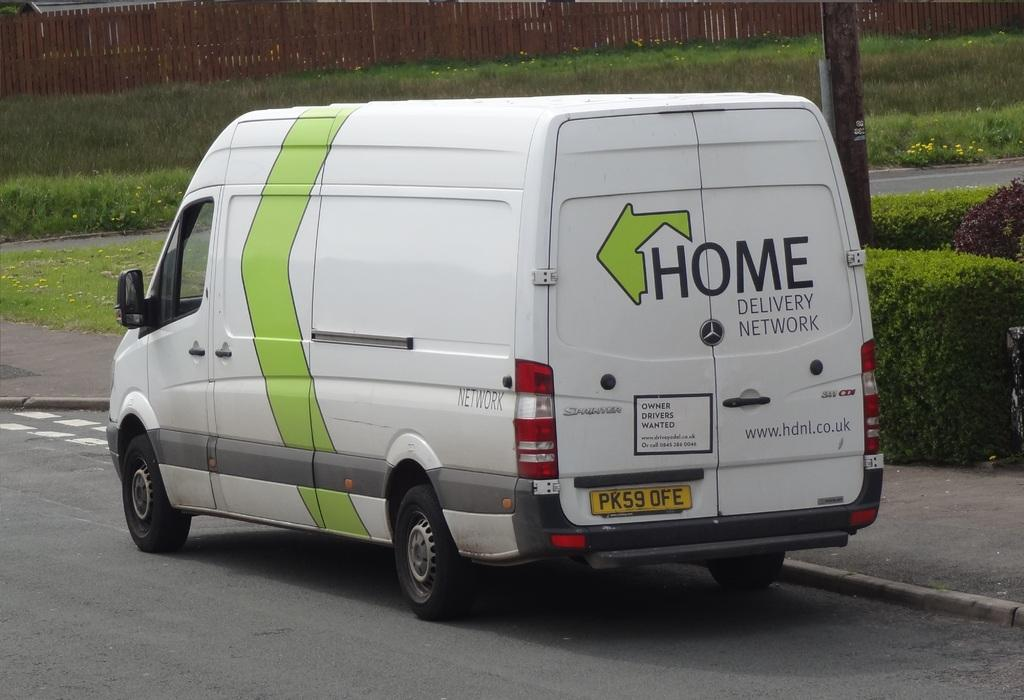Provide a one-sentence caption for the provided image. The green and white van says Home Delivery Network. 